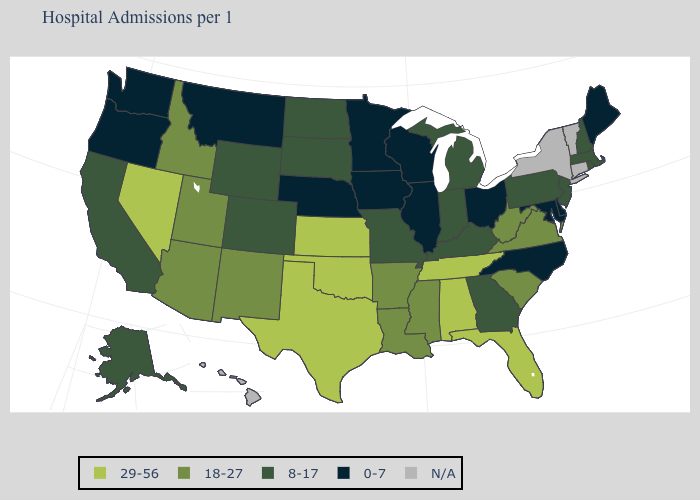What is the value of Ohio?
Write a very short answer. 0-7. Name the states that have a value in the range 0-7?
Keep it brief. Delaware, Illinois, Iowa, Maine, Maryland, Minnesota, Montana, Nebraska, North Carolina, Ohio, Oregon, Washington, Wisconsin. What is the value of Nebraska?
Give a very brief answer. 0-7. Name the states that have a value in the range 18-27?
Give a very brief answer. Arizona, Arkansas, Idaho, Louisiana, Mississippi, New Mexico, South Carolina, Utah, Virginia, West Virginia. Does Nevada have the highest value in the West?
Be succinct. Yes. Name the states that have a value in the range 18-27?
Short answer required. Arizona, Arkansas, Idaho, Louisiana, Mississippi, New Mexico, South Carolina, Utah, Virginia, West Virginia. What is the lowest value in the West?
Quick response, please. 0-7. Does Wisconsin have the lowest value in the USA?
Keep it brief. Yes. Name the states that have a value in the range 18-27?
Write a very short answer. Arizona, Arkansas, Idaho, Louisiana, Mississippi, New Mexico, South Carolina, Utah, Virginia, West Virginia. What is the value of Montana?
Give a very brief answer. 0-7. Which states have the highest value in the USA?
Answer briefly. Alabama, Florida, Kansas, Nevada, Oklahoma, Tennessee, Texas. What is the highest value in states that border Wyoming?
Be succinct. 18-27. What is the highest value in the USA?
Keep it brief. 29-56. What is the lowest value in the USA?
Quick response, please. 0-7. Does Kansas have the highest value in the USA?
Concise answer only. Yes. 